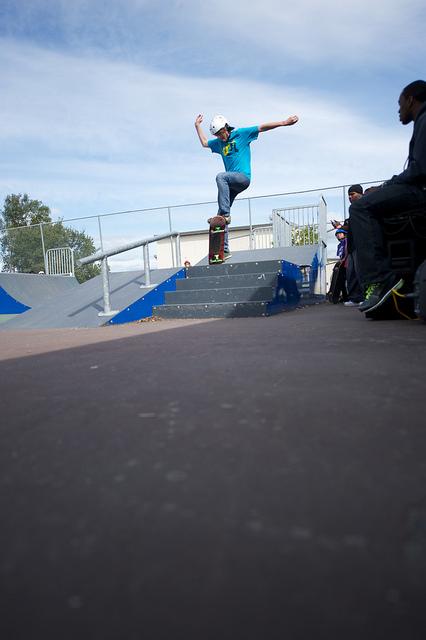What color is the man's shirt?
Write a very short answer. Blue. What is the skateboarder jumping off of?
Answer briefly. Steps. What color is the guys helmet?
Keep it brief. White. 